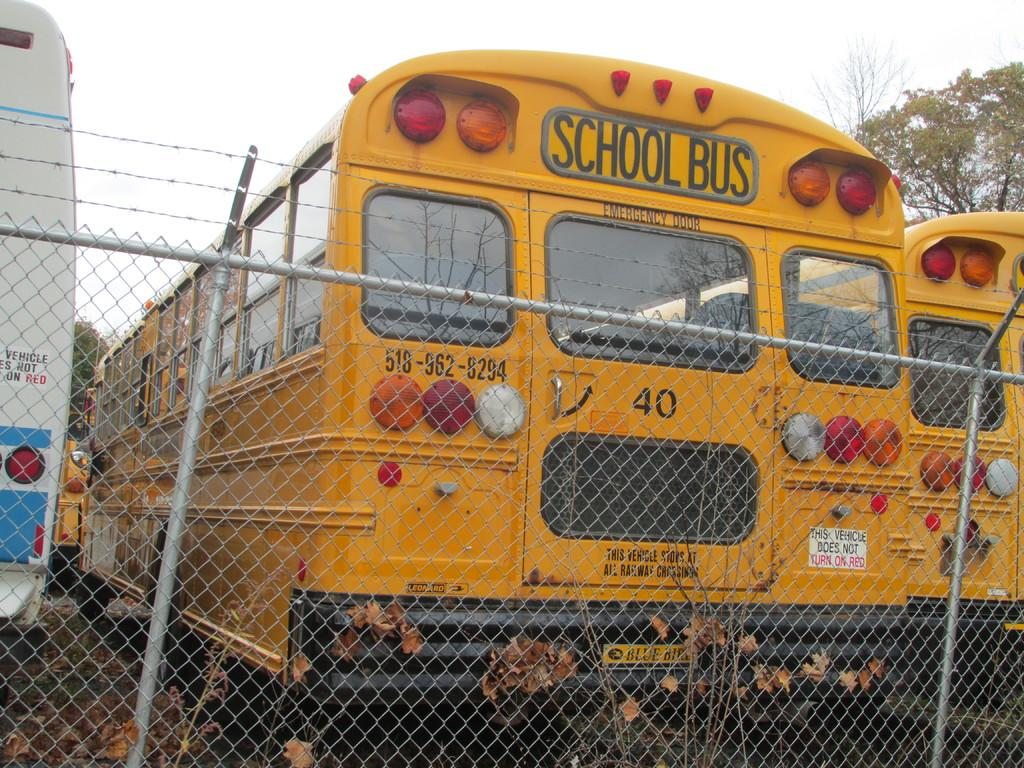What objects are located in the middle of the image? There is a net and metal rods in the middle of the image. What type of vehicles can be seen in the image? There are buses in the image. What can be seen in the background of the image? There are trees in the background of the image. What is visible at the top of the image? The sky is visible at the top of the image. What type of coat is the bus driver wearing in the image? There is no bus driver present in the image, and therefore no coat can be observed. What song is being played by the trees in the background of the image? There are no musical instruments or sounds associated with the trees in the image. 